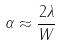Convert formula to latex. <formula><loc_0><loc_0><loc_500><loc_500>\alpha \approx { \frac { 2 \lambda } { W } }</formula> 